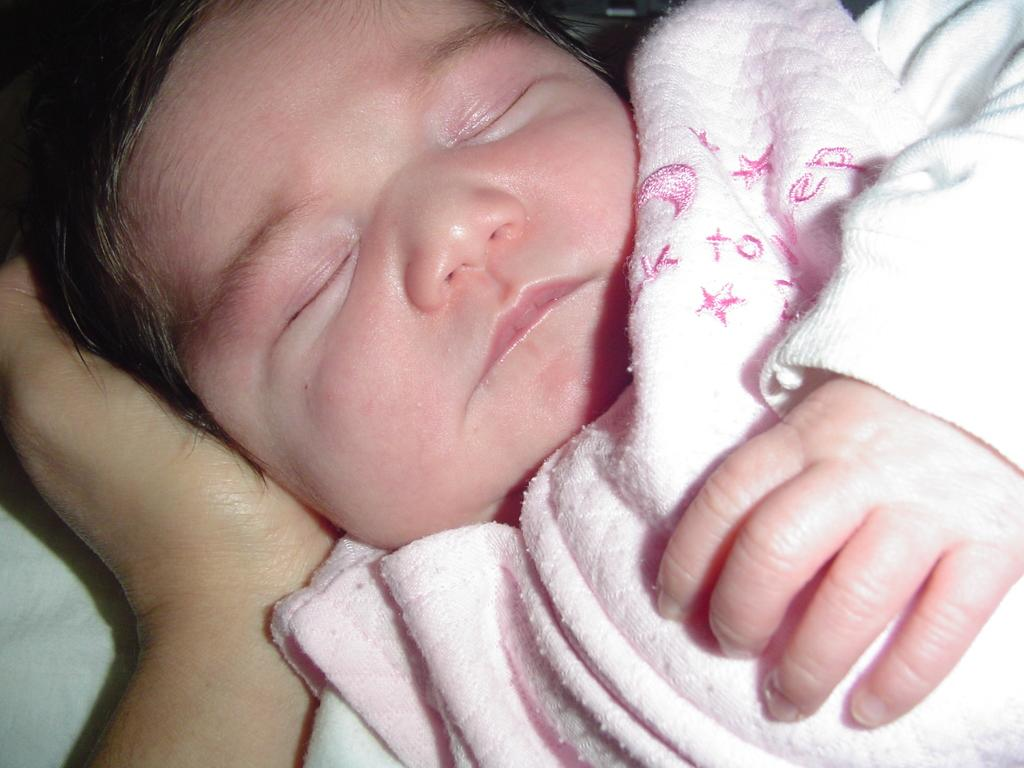What is the main subject of the image? There is a baby in the image. What is the baby doing in the image? The baby is sleeping. What is the baby wearing in the image? The baby is wearing a baby pink dress. Whose hand is visible in the image? There is a person's hand visible in the image. What type of rings can be seen on the baby's fingers in the image? There are no rings visible on the baby's fingers in the image, as the baby is not wearing any. What color is the curtain behind the baby in the image? There is no curtain present in the image; it only shows the baby and a person's hand. 